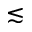Convert formula to latex. <formula><loc_0><loc_0><loc_500><loc_500>\lesssim</formula> 